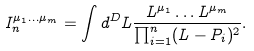<formula> <loc_0><loc_0><loc_500><loc_500>I ^ { \mu _ { 1 } \dots \mu _ { m } } _ { n } = \int d ^ { D } L \frac { L ^ { \mu _ { 1 } } \dots L ^ { \mu _ { m } } } { \prod _ { i = 1 } ^ { n } ( L - P _ { i } ) ^ { 2 } } .</formula> 